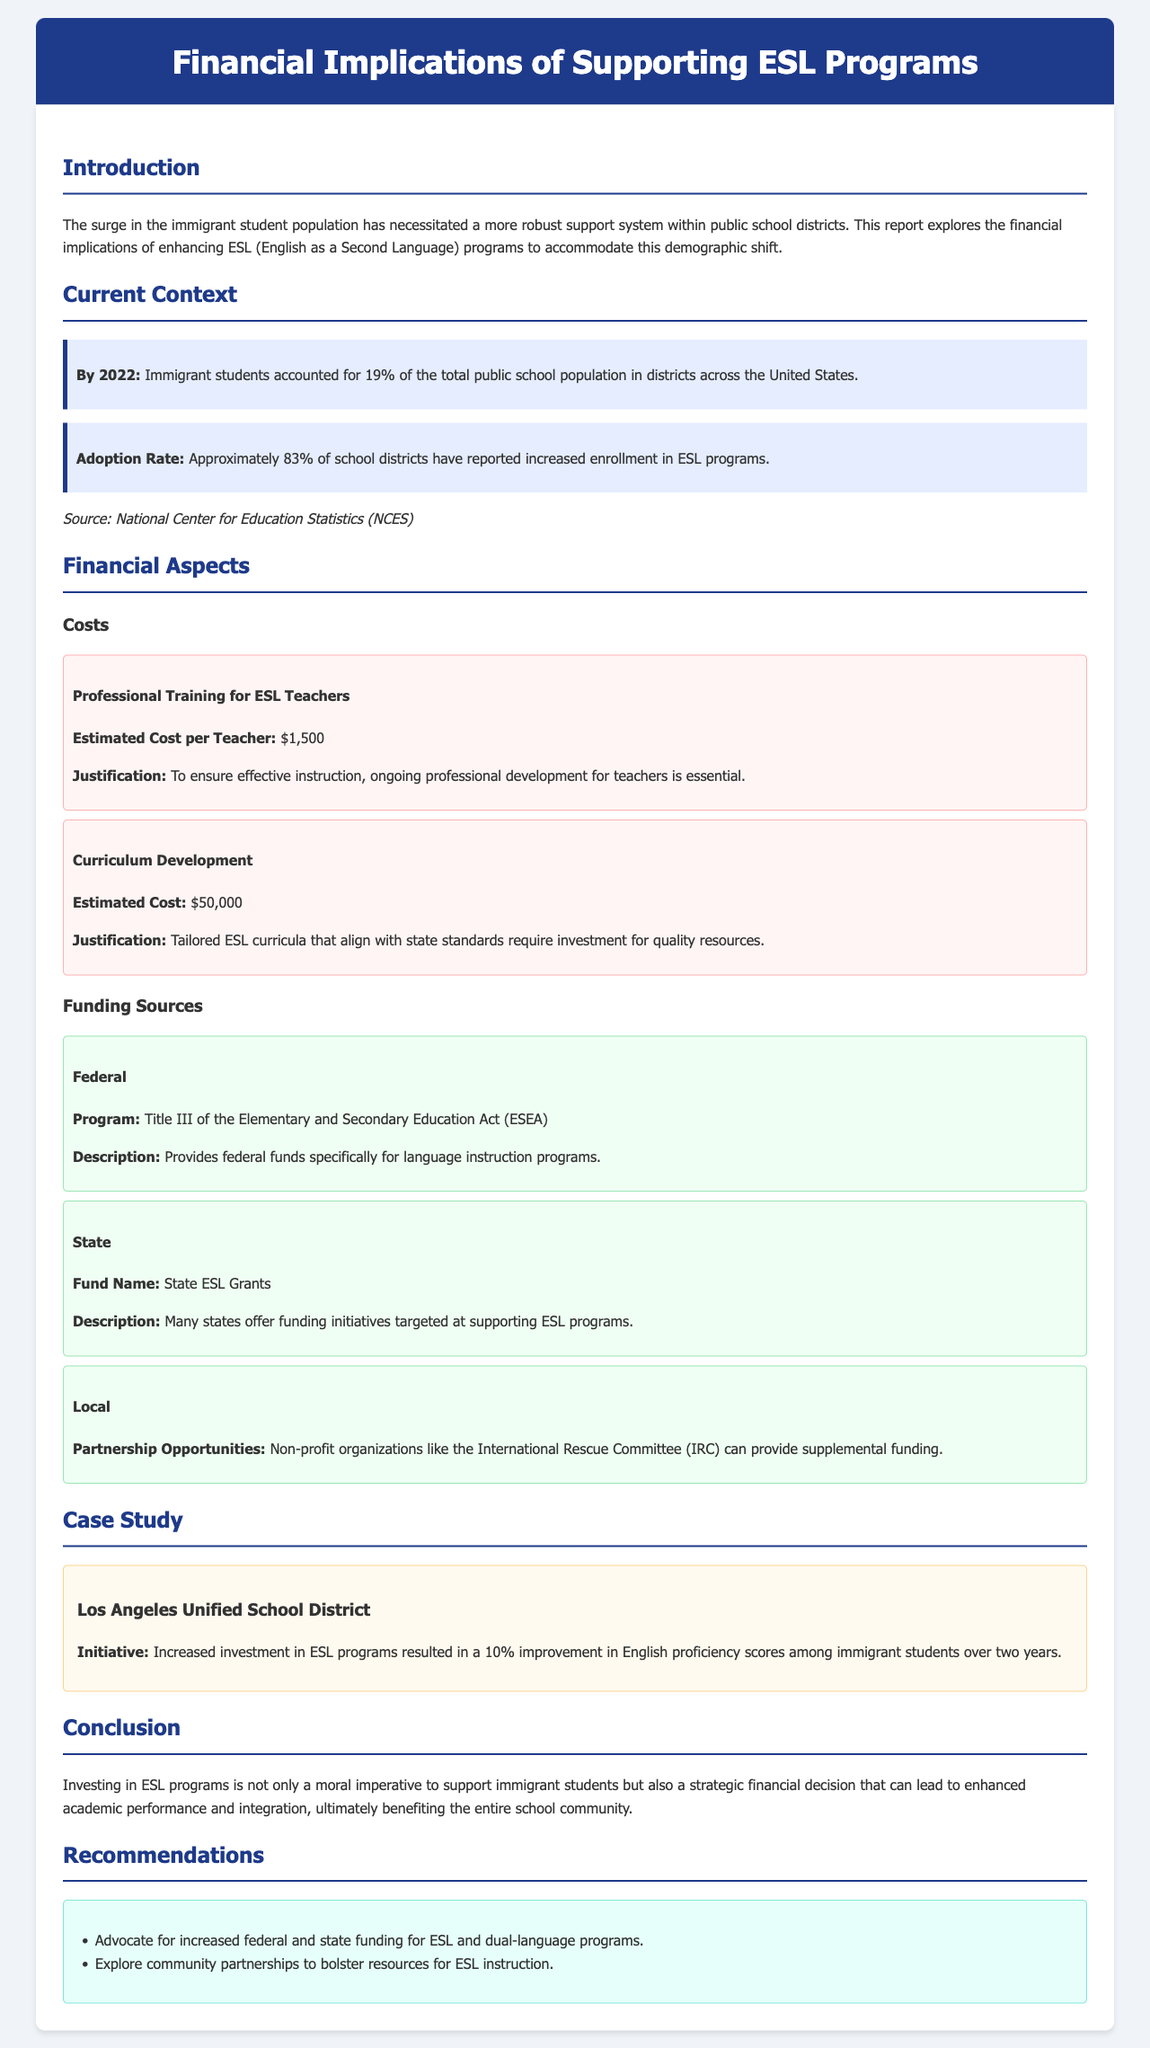What percentage of the public school population did immigrant students account for by 2022? The document states that immigrant students accounted for 19% of the total public school population in districts across the United States by 2022.
Answer: 19% What is the estimated cost for professional training for ESL teachers? The report indicates that the estimated cost per teacher for professional training is $1,500.
Answer: $1,500 What initiative resulted in a 10% improvement in English proficiency scores among immigrant students? The Los Angeles Unified School District's increased investment in ESL programs led to a 10% improvement in English proficiency scores.
Answer: Increased investment in ESL programs Which federal program provides funding specifically for language instruction programs? Title III of the Elementary and Secondary Education Act (ESEA) is the program that provides federal funds for language instruction programs.
Answer: Title III of the Elementary and Secondary Education Act (ESEA) What are two recommendations made in the report? The document recommends advocating for increased funding for ESL programs and exploring community partnerships to bolster resources for ESL instruction.
Answer: Advocate for increased federal and state funding; Explore community partnerships 